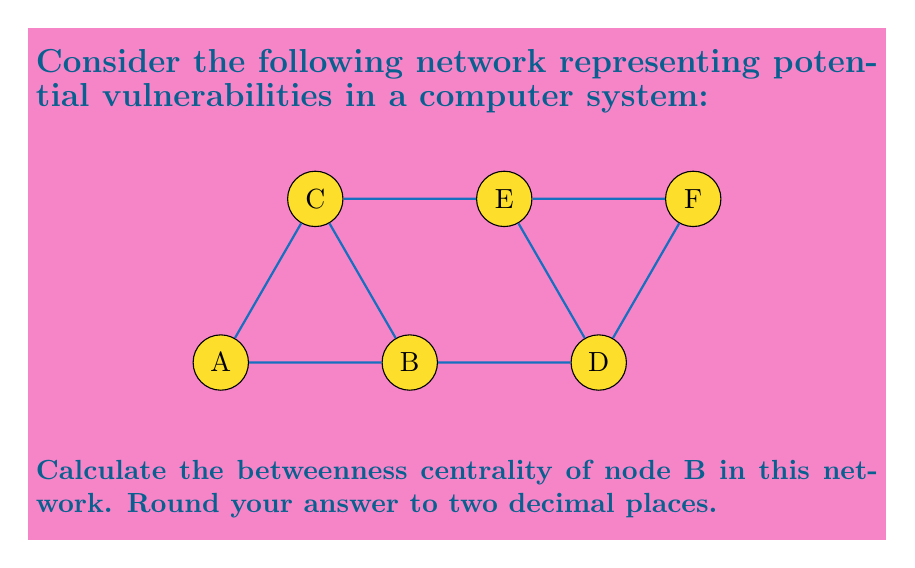Can you answer this question? To calculate the betweenness centrality of node B, we need to follow these steps:

1) First, we need to identify all shortest paths between pairs of nodes in the network.

2) Then, we count how many of these shortest paths pass through node B.

3) The betweenness centrality is calculated using the formula:

   $$C_B(v) = \sum_{s \neq v \neq t} \frac{\sigma_{st}(v)}{\sigma_{st}}$$

   where $\sigma_{st}$ is the total number of shortest paths from node s to node t, and $\sigma_{st}(v)$ is the number of those paths that pass through v.

4) Let's count the shortest paths through B:
   - A to C: 1 path through B out of 1 total
   - A to D: 1 path through B out of 1 total
   - A to E: 1 path through B out of 1 total
   - A to F: 1 path through B out of 1 total
   - C to D: 1 path through B out of 1 total
   - C to F: 1 path through B out of 2 total

5) Summing these up:
   $$C_B(B) = 1 + 1 + 1 + 1 + 1 + \frac{1}{2} = 5.5$$

6) To normalize this, we divide by the number of possible node pairs excluding B:
   $$(6-1)(6-2)/2 = 10$$

7) Therefore, the normalized betweenness centrality of B is:
   $$5.5 / 10 = 0.55$$

Rounding to two decimal places gives us 0.55.
Answer: 0.55 